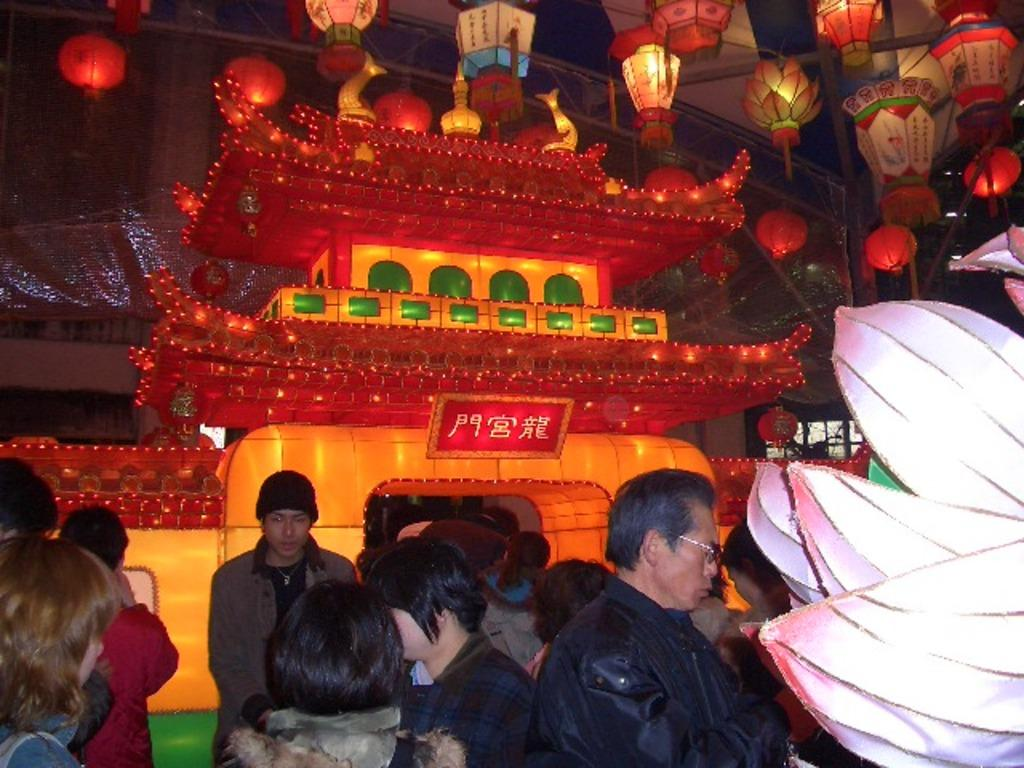How many people can be seen in the image? There are many people in the image. Can you describe the clothing or accessories of any of the people? One person is wearing a cap, and another person is wearing glasses (specs). What type of decorative items are present in the image? The specific decorative items are not mentioned, but they are present in the image. What can be seen hanging in the image? Lights are hanged in the image. How many lizards are crawling on the people in the image? There are no lizards present in the image; it only features people and decorative items. 